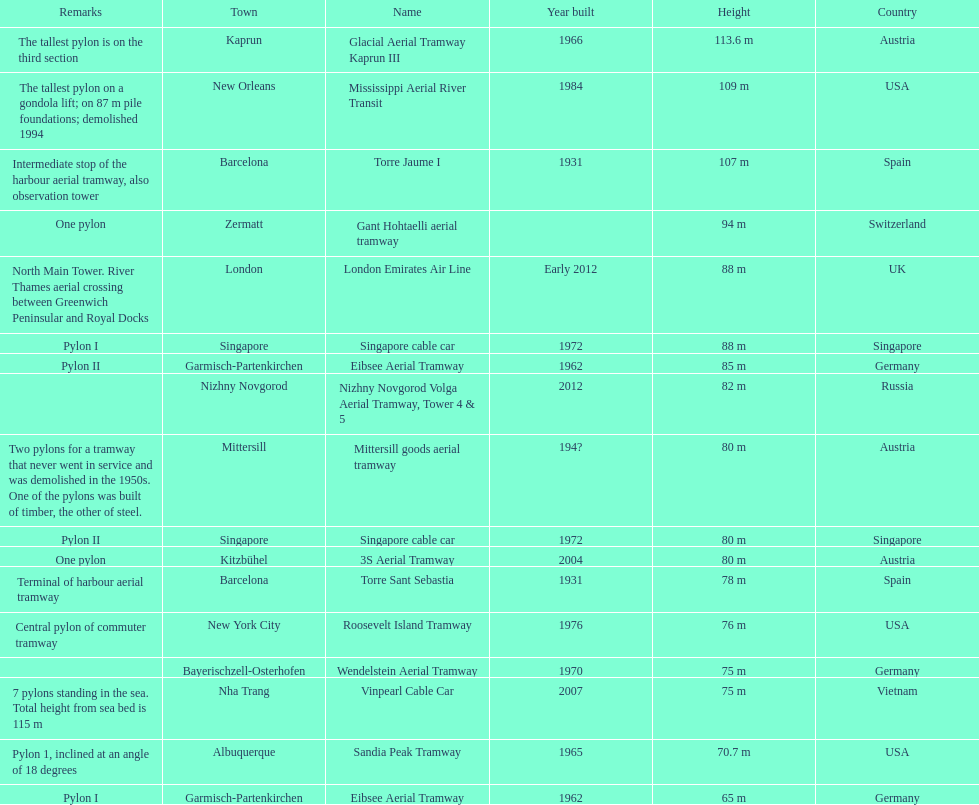What is the pylon with the least height listed here? Eibsee Aerial Tramway. 